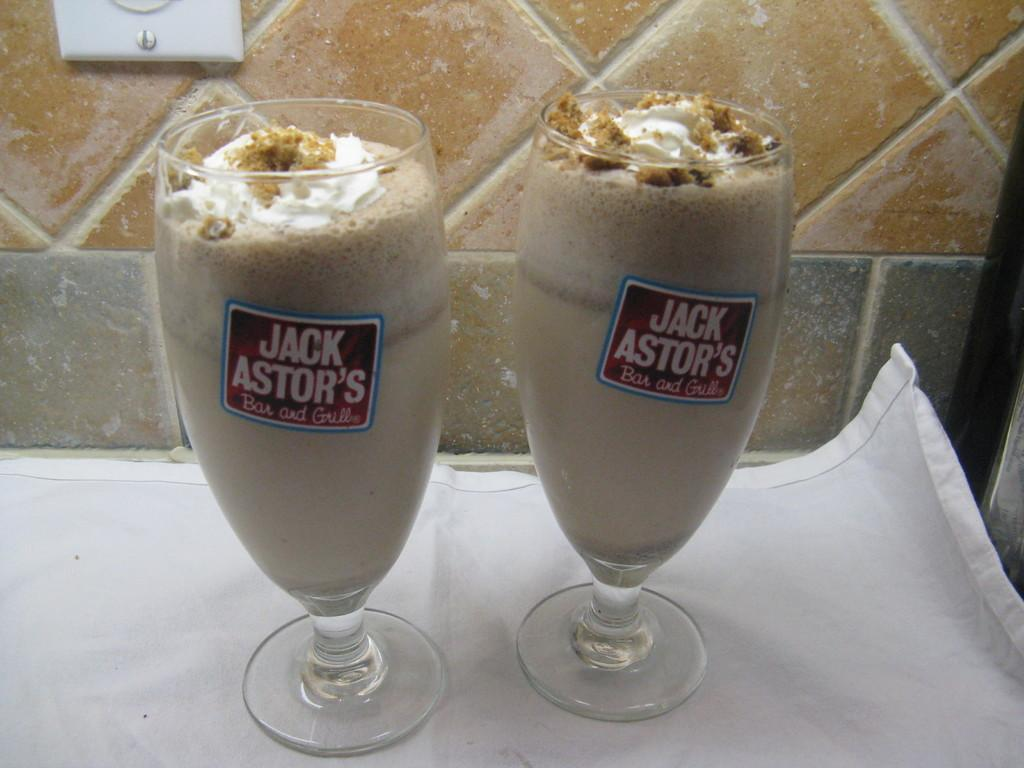How many glasses are visible in the image? There are two glasses in the image. What is inside the glasses? The glasses contain chocolate milkshake. Where are the glasses placed? The glasses are on a table cloth. Can you see any pigs in the image? There are no pigs present in the image. What type of pain might the glasses be experiencing in the image? The glasses are inanimate objects and cannot experience pain. 